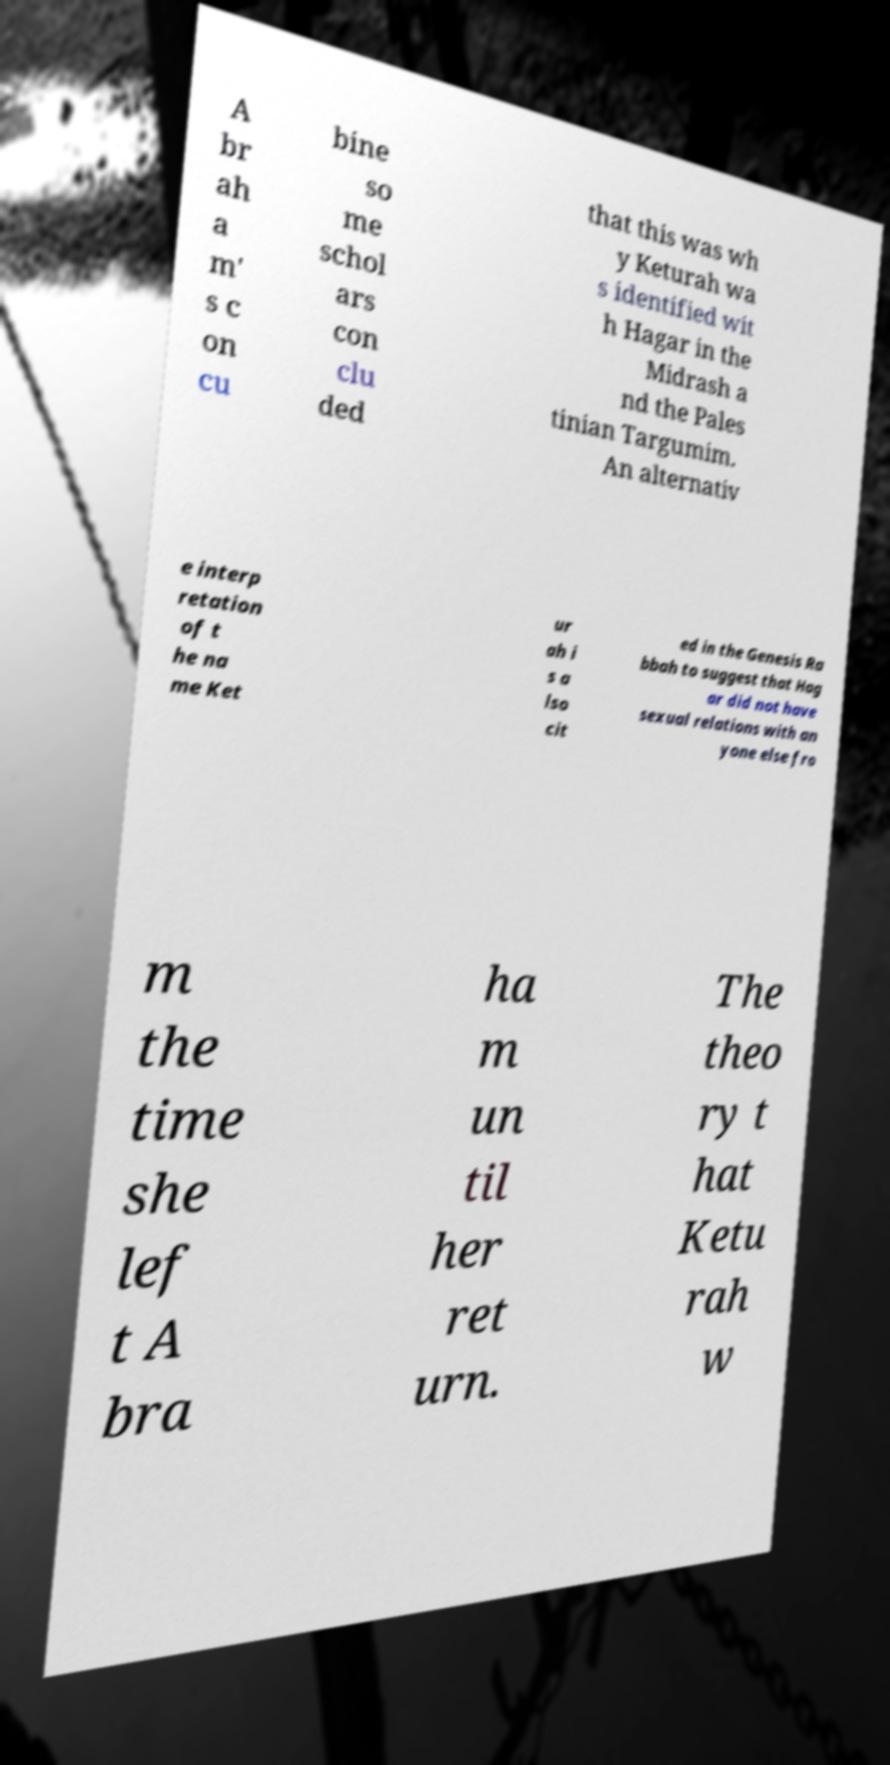Could you extract and type out the text from this image? A br ah a m' s c on cu bine so me schol ars con clu ded that this was wh y Keturah wa s identified wit h Hagar in the Midrash a nd the Pales tinian Targumim. An alternativ e interp retation of t he na me Ket ur ah i s a lso cit ed in the Genesis Ra bbah to suggest that Hag ar did not have sexual relations with an yone else fro m the time she lef t A bra ha m un til her ret urn. The theo ry t hat Ketu rah w 